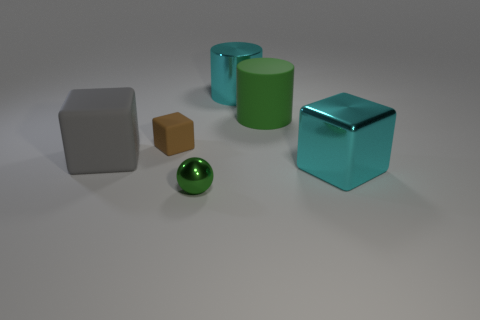Add 1 big gray matte things. How many objects exist? 7 Subtract all cylinders. How many objects are left? 4 Add 5 balls. How many balls are left? 6 Add 2 big green things. How many big green things exist? 3 Subtract all green cylinders. How many cylinders are left? 1 Subtract all matte cubes. How many cubes are left? 1 Subtract 1 cyan blocks. How many objects are left? 5 Subtract 2 cylinders. How many cylinders are left? 0 Subtract all gray balls. Subtract all purple blocks. How many balls are left? 1 Subtract all blue cubes. How many yellow cylinders are left? 0 